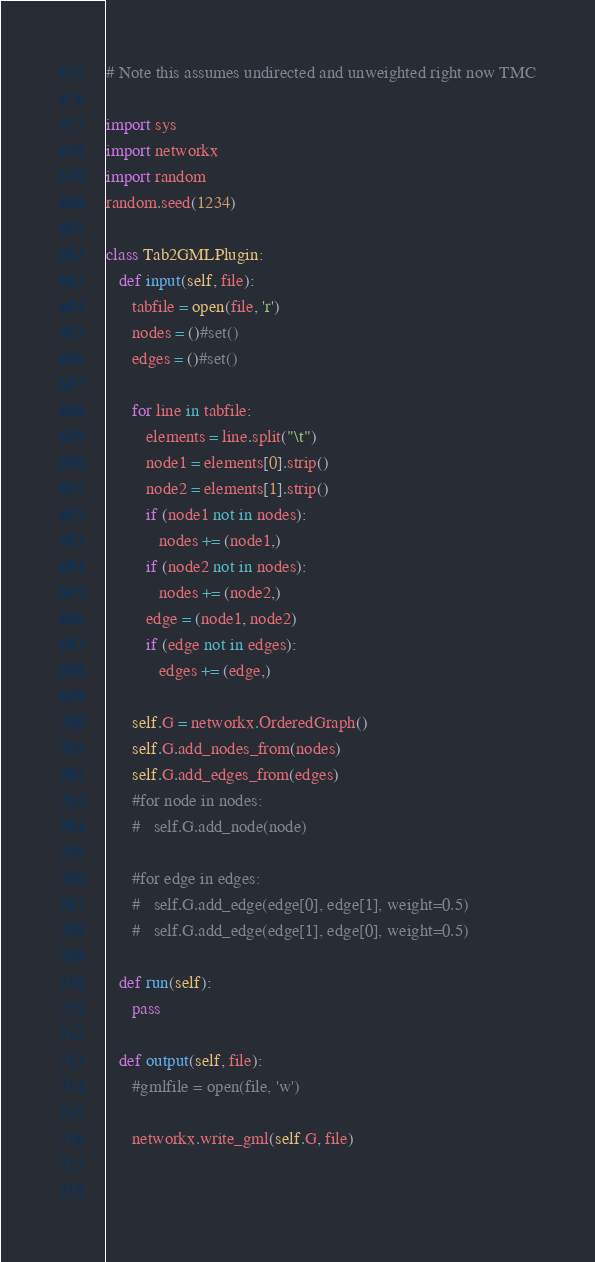<code> <loc_0><loc_0><loc_500><loc_500><_Python_># Note this assumes undirected and unweighted right now TMC

import sys
import networkx
import random
random.seed(1234)

class Tab2GMLPlugin:
   def input(self, file):
      tabfile = open(file, 'r')
      nodes = ()#set()
      edges = ()#set()

      for line in tabfile:
         elements = line.split("\t")
         node1 = elements[0].strip()
         node2 = elements[1].strip()
         if (node1 not in nodes):
            nodes += (node1,)
         if (node2 not in nodes):
            nodes += (node2,)
         edge = (node1, node2)
         if (edge not in edges):
            edges += (edge,)

      self.G = networkx.OrderedGraph()
      self.G.add_nodes_from(nodes)
      self.G.add_edges_from(edges)
      #for node in nodes:
      #   self.G.add_node(node)

      #for edge in edges:
      #   self.G.add_edge(edge[0], edge[1], weight=0.5)
      #   self.G.add_edge(edge[1], edge[0], weight=0.5)

   def run(self):
      pass

   def output(self, file):
      #gmlfile = open(file, 'w')

      networkx.write_gml(self.G, file)

 

</code> 